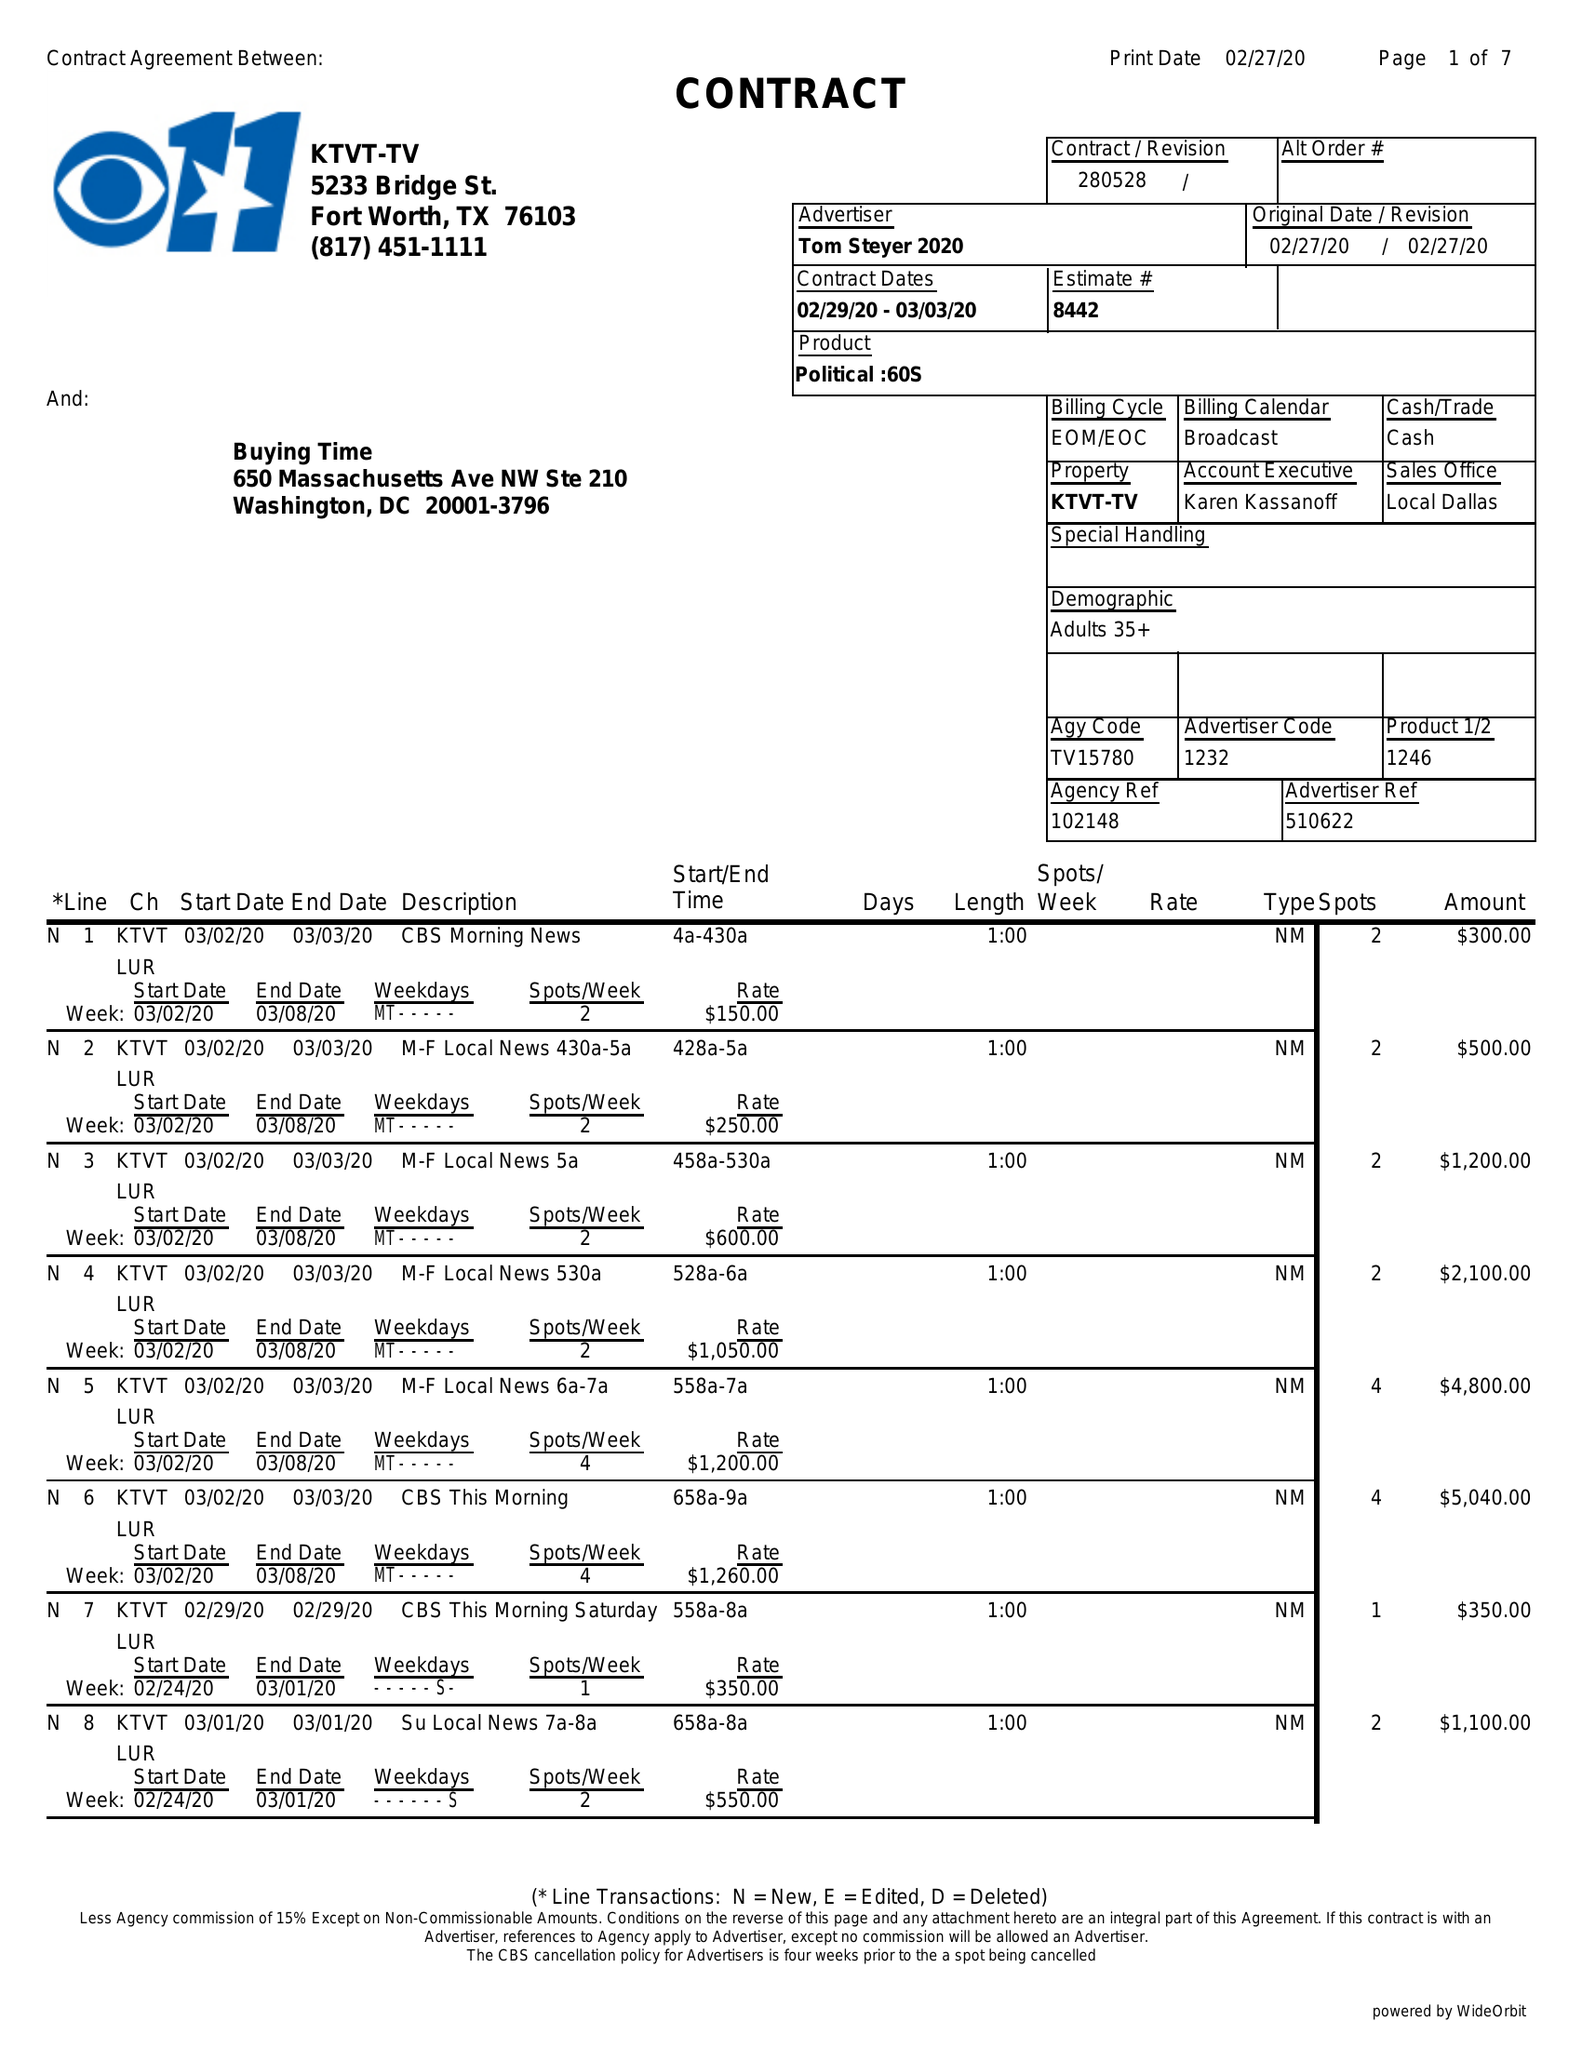What is the value for the flight_from?
Answer the question using a single word or phrase. 02/29/20 